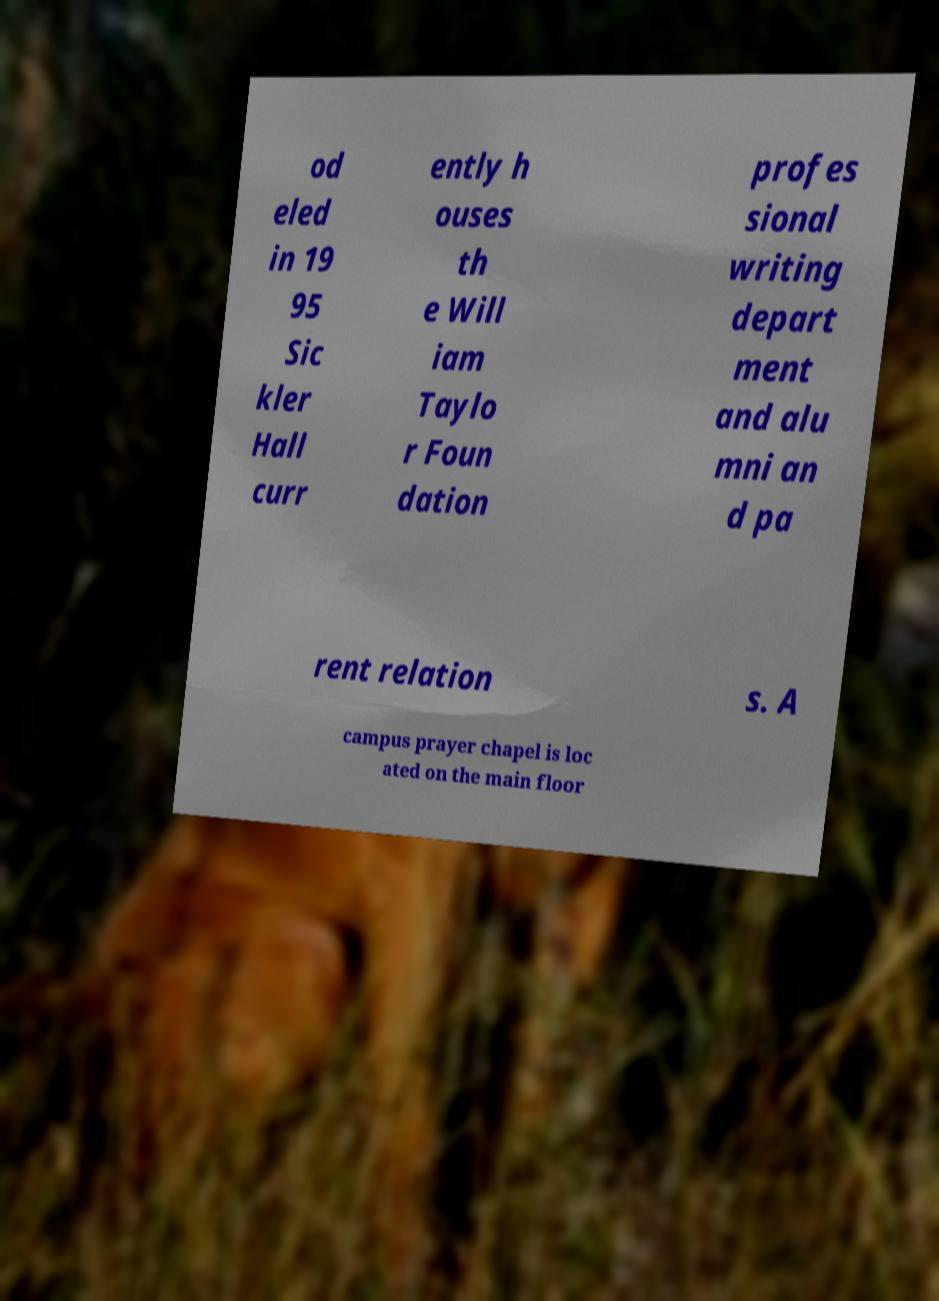Can you accurately transcribe the text from the provided image for me? od eled in 19 95 Sic kler Hall curr ently h ouses th e Will iam Taylo r Foun dation profes sional writing depart ment and alu mni an d pa rent relation s. A campus prayer chapel is loc ated on the main floor 